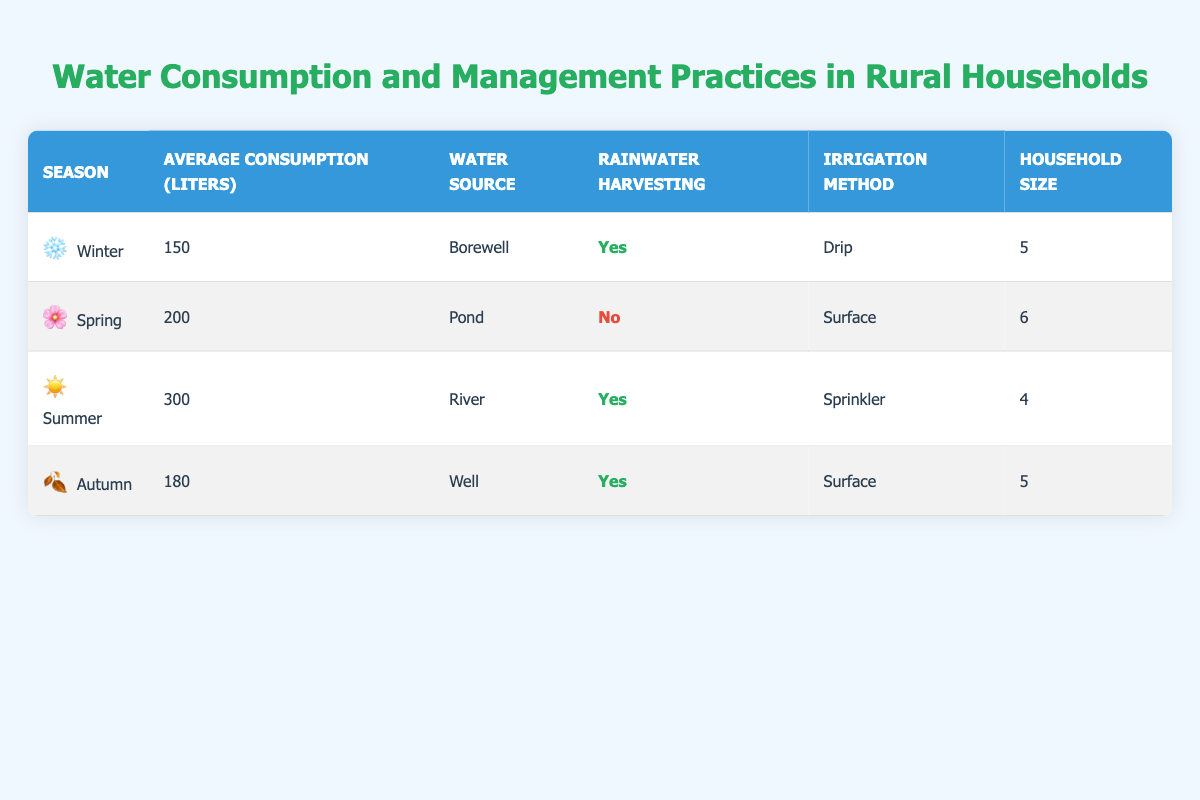What is the average water consumption per household in summer? According to the table, the average consumption per household in summer is listed as 300 liters.
Answer: 300 liters Which season has the highest average water consumption per household? By comparing the average consumption values across seasons, summer has the highest average consumption at 300 liters, while winter, spring, and autumn have lower values of 150, 200, and 180 liters respectively.
Answer: Summer Is rainwater harvesting practiced in spring? The table indicates that during spring, rainwater harvesting is marked as "No".
Answer: No What is the total average water consumption per household across all seasons? To find the total average consumption, we add the average consumptions for all seasons: (150 + 200 + 300 + 180) = 830 liters. Since there are 4 seasons, we calculate the average as 830/4 = 207.5 liters.
Answer: 207.5 liters How many households utilize drip irrigation in the winter? The winter season shows that a drip irrigation method is used by one household type as shown in the table without any indication of multiple households or variations in methods, thus it's one type as per that row.
Answer: One household type How does the average consumption in autumn compare to that in winter? The average consumption in autumn is 180 liters, while in winter it is 150 liters. To compare, we see that autumn has an average consumption that exceeds winter by 30 liters (180 - 150 = 30).
Answer: Autumn exceeds winter by 30 liters Is the water source for summer households the river? Looking at the table indicates that the water source for households in summer is indeed the river, as explicitly stated.
Answer: Yes What is the average household size across all seasons? To determine the average household size, we add the sizes together: (5 + 6 + 4 + 5) = 20, then we find the average by dividing by the number of seasons which is 20/4 = 5.
Answer: 5 In which season is pond water used as a source? The table specifies that during spring, the water source utilized is a pond.
Answer: Spring 